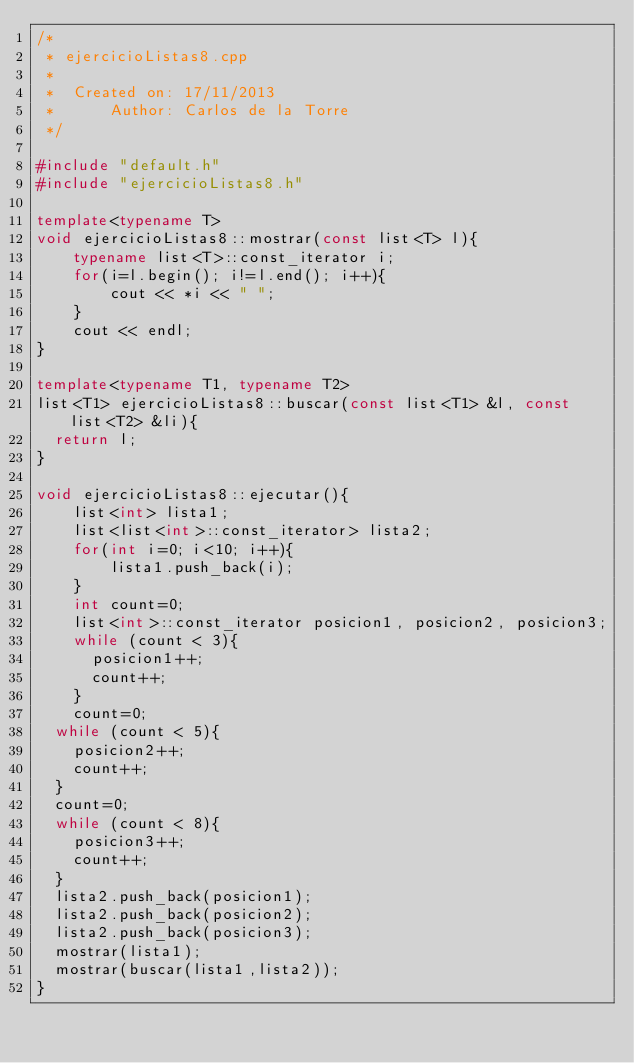<code> <loc_0><loc_0><loc_500><loc_500><_C++_>/*
 * ejercicioListas8.cpp
 *
 *  Created on: 17/11/2013
 *      Author: Carlos de la Torre
 */

#include "default.h"
#include "ejercicioListas8.h"

template<typename T>
void ejercicioListas8::mostrar(const list<T> l){
    typename list<T>::const_iterator i;
    for(i=l.begin(); i!=l.end(); i++){
        cout << *i << " ";
    }
    cout << endl;
}

template<typename T1, typename T2>
list<T1> ejercicioListas8::buscar(const list<T1> &l, const list<T2> &li){
	return l;
}

void ejercicioListas8::ejecutar(){
    list<int> lista1;
    list<list<int>::const_iterator> lista2;
    for(int i=0; i<10; i++){
        lista1.push_back(i);
    }
    int count=0;
    list<int>::const_iterator posicion1, posicion2, posicion3;
    while (count < 3){
    	posicion1++;
    	count++;
    }
    count=0;
	while (count < 5){
		posicion2++;
		count++;
	}
	count=0;
	while (count < 8){
		posicion3++;
		count++;
	}
	lista2.push_back(posicion1);
	lista2.push_back(posicion2);
	lista2.push_back(posicion3);
	mostrar(lista1);
	mostrar(buscar(lista1,lista2));
}
</code> 